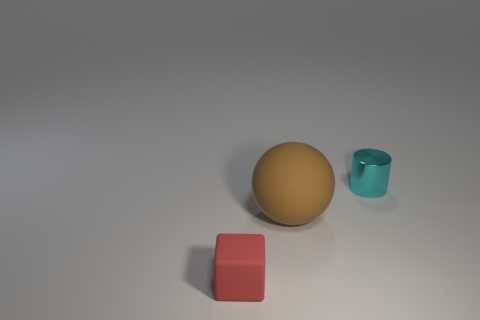What number of big spheres are made of the same material as the tiny red block?
Keep it short and to the point. 1. There is a rubber thing left of the rubber object that is behind the tiny thing in front of the small cyan cylinder; what is its size?
Ensure brevity in your answer.  Small. There is a small red object; how many tiny red cubes are left of it?
Provide a succinct answer. 0. Are there more small red cubes than gray metallic cylinders?
Make the answer very short. Yes. There is a thing that is to the left of the tiny cyan cylinder and to the right of the tiny matte block; what size is it?
Offer a very short reply. Large. There is a object on the left side of the rubber thing that is to the right of the small object on the left side of the shiny cylinder; what is its material?
Your answer should be very brief. Rubber. Does the small thing that is left of the small cyan shiny cylinder have the same color as the small thing that is to the right of the large brown object?
Make the answer very short. No. There is a tiny thing to the right of the small thing that is left of the tiny thing behind the big brown matte object; what is its shape?
Offer a very short reply. Cylinder. What is the shape of the object that is in front of the small cylinder and behind the small red thing?
Your answer should be very brief. Sphere. There is a small thing on the left side of the small object behind the sphere; what number of tiny things are right of it?
Your answer should be compact. 1. 